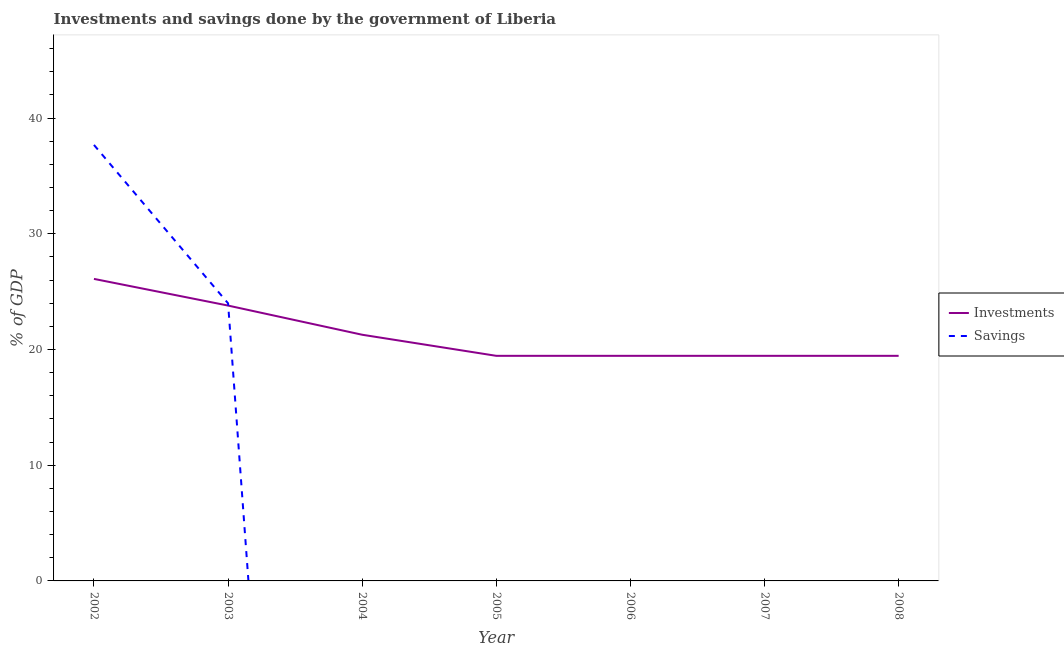How many different coloured lines are there?
Provide a short and direct response. 2. Does the line corresponding to investments of government intersect with the line corresponding to savings of government?
Give a very brief answer. Yes. Is the number of lines equal to the number of legend labels?
Your answer should be very brief. No. What is the savings of government in 2007?
Your answer should be compact. 0. Across all years, what is the maximum savings of government?
Offer a terse response. 37.68. Across all years, what is the minimum savings of government?
Give a very brief answer. 0. In which year was the investments of government maximum?
Keep it short and to the point. 2002. What is the total investments of government in the graph?
Keep it short and to the point. 149. What is the difference between the investments of government in 2003 and that in 2007?
Keep it short and to the point. 4.34. What is the difference between the savings of government in 2005 and the investments of government in 2003?
Offer a terse response. -23.8. What is the average investments of government per year?
Keep it short and to the point. 21.29. In the year 2003, what is the difference between the investments of government and savings of government?
Ensure brevity in your answer.  -0.19. What is the difference between the highest and the second highest investments of government?
Your response must be concise. 2.31. What is the difference between the highest and the lowest investments of government?
Provide a short and direct response. 6.65. In how many years, is the savings of government greater than the average savings of government taken over all years?
Keep it short and to the point. 2. Is the sum of the investments of government in 2003 and 2008 greater than the maximum savings of government across all years?
Ensure brevity in your answer.  Yes. Does the investments of government monotonically increase over the years?
Offer a very short reply. No. Is the savings of government strictly greater than the investments of government over the years?
Offer a very short reply. No. How many years are there in the graph?
Provide a succinct answer. 7. Are the values on the major ticks of Y-axis written in scientific E-notation?
Offer a terse response. No. Does the graph contain grids?
Offer a terse response. No. How many legend labels are there?
Keep it short and to the point. 2. How are the legend labels stacked?
Keep it short and to the point. Vertical. What is the title of the graph?
Provide a short and direct response. Investments and savings done by the government of Liberia. Does "Resident" appear as one of the legend labels in the graph?
Provide a short and direct response. No. What is the label or title of the X-axis?
Your response must be concise. Year. What is the label or title of the Y-axis?
Provide a succinct answer. % of GDP. What is the % of GDP of Investments in 2002?
Provide a succinct answer. 26.1. What is the % of GDP of Savings in 2002?
Ensure brevity in your answer.  37.68. What is the % of GDP in Investments in 2003?
Offer a very short reply. 23.8. What is the % of GDP in Savings in 2003?
Ensure brevity in your answer.  23.99. What is the % of GDP in Investments in 2004?
Keep it short and to the point. 21.28. What is the % of GDP of Savings in 2004?
Ensure brevity in your answer.  0. What is the % of GDP in Investments in 2005?
Offer a terse response. 19.45. What is the % of GDP in Savings in 2005?
Offer a very short reply. 0. What is the % of GDP in Investments in 2006?
Provide a short and direct response. 19.45. What is the % of GDP in Investments in 2007?
Ensure brevity in your answer.  19.45. What is the % of GDP of Savings in 2007?
Offer a terse response. 0. What is the % of GDP of Investments in 2008?
Provide a short and direct response. 19.45. Across all years, what is the maximum % of GDP of Investments?
Ensure brevity in your answer.  26.1. Across all years, what is the maximum % of GDP of Savings?
Keep it short and to the point. 37.68. Across all years, what is the minimum % of GDP of Investments?
Make the answer very short. 19.45. What is the total % of GDP in Investments in the graph?
Your answer should be compact. 149. What is the total % of GDP of Savings in the graph?
Your answer should be very brief. 61.67. What is the difference between the % of GDP of Investments in 2002 and that in 2003?
Ensure brevity in your answer.  2.31. What is the difference between the % of GDP of Savings in 2002 and that in 2003?
Your answer should be very brief. 13.69. What is the difference between the % of GDP of Investments in 2002 and that in 2004?
Your response must be concise. 4.83. What is the difference between the % of GDP in Investments in 2002 and that in 2005?
Your answer should be very brief. 6.65. What is the difference between the % of GDP of Investments in 2002 and that in 2006?
Your answer should be very brief. 6.65. What is the difference between the % of GDP of Investments in 2002 and that in 2007?
Provide a succinct answer. 6.65. What is the difference between the % of GDP in Investments in 2002 and that in 2008?
Keep it short and to the point. 6.65. What is the difference between the % of GDP in Investments in 2003 and that in 2004?
Your answer should be very brief. 2.52. What is the difference between the % of GDP of Investments in 2003 and that in 2005?
Provide a short and direct response. 4.34. What is the difference between the % of GDP of Investments in 2003 and that in 2006?
Provide a short and direct response. 4.34. What is the difference between the % of GDP in Investments in 2003 and that in 2007?
Ensure brevity in your answer.  4.34. What is the difference between the % of GDP in Investments in 2003 and that in 2008?
Offer a very short reply. 4.34. What is the difference between the % of GDP of Investments in 2004 and that in 2005?
Provide a short and direct response. 1.82. What is the difference between the % of GDP of Investments in 2004 and that in 2006?
Provide a short and direct response. 1.82. What is the difference between the % of GDP in Investments in 2004 and that in 2007?
Your answer should be very brief. 1.82. What is the difference between the % of GDP of Investments in 2004 and that in 2008?
Ensure brevity in your answer.  1.82. What is the difference between the % of GDP in Investments in 2006 and that in 2008?
Your answer should be compact. 0. What is the difference between the % of GDP of Investments in 2007 and that in 2008?
Offer a terse response. 0. What is the difference between the % of GDP of Investments in 2002 and the % of GDP of Savings in 2003?
Make the answer very short. 2.11. What is the average % of GDP in Investments per year?
Your answer should be very brief. 21.29. What is the average % of GDP of Savings per year?
Provide a succinct answer. 8.81. In the year 2002, what is the difference between the % of GDP in Investments and % of GDP in Savings?
Make the answer very short. -11.58. In the year 2003, what is the difference between the % of GDP in Investments and % of GDP in Savings?
Provide a short and direct response. -0.19. What is the ratio of the % of GDP of Investments in 2002 to that in 2003?
Your answer should be very brief. 1.1. What is the ratio of the % of GDP in Savings in 2002 to that in 2003?
Your answer should be compact. 1.57. What is the ratio of the % of GDP in Investments in 2002 to that in 2004?
Provide a succinct answer. 1.23. What is the ratio of the % of GDP in Investments in 2002 to that in 2005?
Your response must be concise. 1.34. What is the ratio of the % of GDP of Investments in 2002 to that in 2006?
Make the answer very short. 1.34. What is the ratio of the % of GDP of Investments in 2002 to that in 2007?
Provide a succinct answer. 1.34. What is the ratio of the % of GDP in Investments in 2002 to that in 2008?
Your answer should be compact. 1.34. What is the ratio of the % of GDP in Investments in 2003 to that in 2004?
Ensure brevity in your answer.  1.12. What is the ratio of the % of GDP of Investments in 2003 to that in 2005?
Give a very brief answer. 1.22. What is the ratio of the % of GDP of Investments in 2003 to that in 2006?
Give a very brief answer. 1.22. What is the ratio of the % of GDP in Investments in 2003 to that in 2007?
Make the answer very short. 1.22. What is the ratio of the % of GDP of Investments in 2003 to that in 2008?
Your response must be concise. 1.22. What is the ratio of the % of GDP of Investments in 2004 to that in 2005?
Your response must be concise. 1.09. What is the ratio of the % of GDP in Investments in 2004 to that in 2006?
Your answer should be very brief. 1.09. What is the ratio of the % of GDP in Investments in 2004 to that in 2007?
Your response must be concise. 1.09. What is the ratio of the % of GDP in Investments in 2004 to that in 2008?
Provide a succinct answer. 1.09. What is the ratio of the % of GDP of Investments in 2006 to that in 2007?
Make the answer very short. 1. What is the ratio of the % of GDP of Investments in 2006 to that in 2008?
Offer a terse response. 1. What is the difference between the highest and the second highest % of GDP of Investments?
Your answer should be compact. 2.31. What is the difference between the highest and the lowest % of GDP in Investments?
Give a very brief answer. 6.65. What is the difference between the highest and the lowest % of GDP of Savings?
Give a very brief answer. 37.68. 